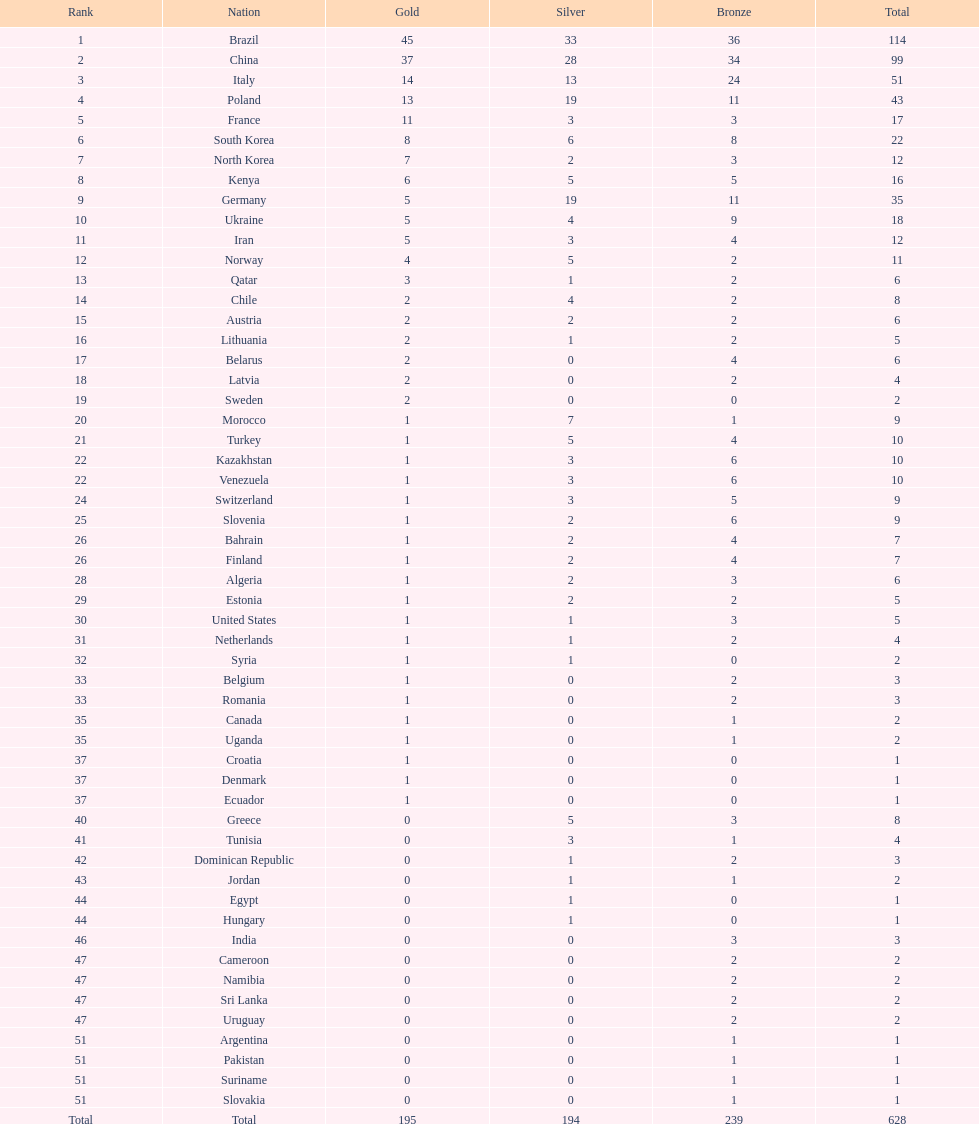Which nation obtained the greatest amount of gold medals? Brazil. 